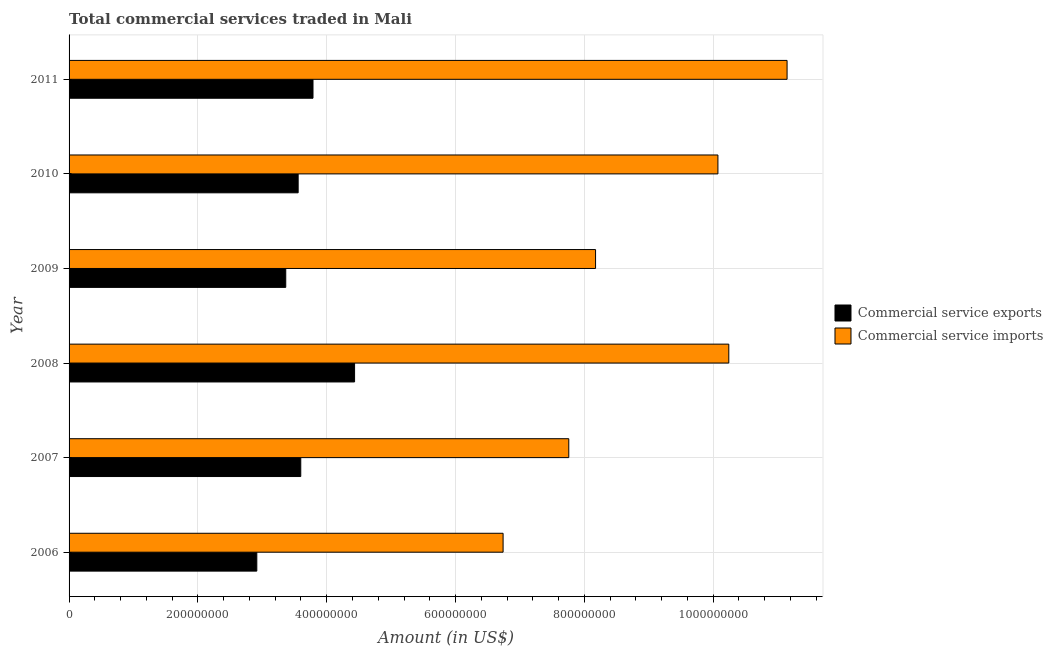How many different coloured bars are there?
Your answer should be very brief. 2. How many bars are there on the 6th tick from the bottom?
Ensure brevity in your answer.  2. What is the label of the 5th group of bars from the top?
Provide a succinct answer. 2007. In how many cases, is the number of bars for a given year not equal to the number of legend labels?
Offer a very short reply. 0. What is the amount of commercial service imports in 2007?
Provide a succinct answer. 7.76e+08. Across all years, what is the maximum amount of commercial service imports?
Offer a very short reply. 1.11e+09. Across all years, what is the minimum amount of commercial service exports?
Your answer should be very brief. 2.91e+08. In which year was the amount of commercial service imports maximum?
Your answer should be compact. 2011. What is the total amount of commercial service imports in the graph?
Give a very brief answer. 5.41e+09. What is the difference between the amount of commercial service imports in 2009 and that in 2011?
Your answer should be compact. -2.97e+08. What is the difference between the amount of commercial service imports in 2006 and the amount of commercial service exports in 2007?
Offer a very short reply. 3.14e+08. What is the average amount of commercial service imports per year?
Your response must be concise. 9.02e+08. In the year 2010, what is the difference between the amount of commercial service exports and amount of commercial service imports?
Your answer should be very brief. -6.52e+08. What is the ratio of the amount of commercial service imports in 2008 to that in 2009?
Keep it short and to the point. 1.25. What is the difference between the highest and the second highest amount of commercial service exports?
Provide a short and direct response. 6.45e+07. What is the difference between the highest and the lowest amount of commercial service exports?
Give a very brief answer. 1.52e+08. What does the 2nd bar from the top in 2009 represents?
Ensure brevity in your answer.  Commercial service exports. What does the 2nd bar from the bottom in 2007 represents?
Give a very brief answer. Commercial service imports. How many years are there in the graph?
Ensure brevity in your answer.  6. Where does the legend appear in the graph?
Your answer should be compact. Center right. What is the title of the graph?
Your response must be concise. Total commercial services traded in Mali. Does "National Visitors" appear as one of the legend labels in the graph?
Provide a succinct answer. No. What is the label or title of the X-axis?
Offer a terse response. Amount (in US$). What is the label or title of the Y-axis?
Keep it short and to the point. Year. What is the Amount (in US$) in Commercial service exports in 2006?
Your answer should be very brief. 2.91e+08. What is the Amount (in US$) of Commercial service imports in 2006?
Your answer should be compact. 6.74e+08. What is the Amount (in US$) of Commercial service exports in 2007?
Keep it short and to the point. 3.60e+08. What is the Amount (in US$) of Commercial service imports in 2007?
Keep it short and to the point. 7.76e+08. What is the Amount (in US$) in Commercial service exports in 2008?
Offer a very short reply. 4.43e+08. What is the Amount (in US$) in Commercial service imports in 2008?
Give a very brief answer. 1.02e+09. What is the Amount (in US$) of Commercial service exports in 2009?
Give a very brief answer. 3.36e+08. What is the Amount (in US$) of Commercial service imports in 2009?
Provide a short and direct response. 8.17e+08. What is the Amount (in US$) of Commercial service exports in 2010?
Offer a terse response. 3.56e+08. What is the Amount (in US$) in Commercial service imports in 2010?
Make the answer very short. 1.01e+09. What is the Amount (in US$) in Commercial service exports in 2011?
Offer a very short reply. 3.79e+08. What is the Amount (in US$) in Commercial service imports in 2011?
Offer a terse response. 1.11e+09. Across all years, what is the maximum Amount (in US$) in Commercial service exports?
Your answer should be very brief. 4.43e+08. Across all years, what is the maximum Amount (in US$) of Commercial service imports?
Ensure brevity in your answer.  1.11e+09. Across all years, what is the minimum Amount (in US$) of Commercial service exports?
Your answer should be very brief. 2.91e+08. Across all years, what is the minimum Amount (in US$) of Commercial service imports?
Your answer should be compact. 6.74e+08. What is the total Amount (in US$) of Commercial service exports in the graph?
Make the answer very short. 2.17e+09. What is the total Amount (in US$) in Commercial service imports in the graph?
Offer a very short reply. 5.41e+09. What is the difference between the Amount (in US$) in Commercial service exports in 2006 and that in 2007?
Your response must be concise. -6.82e+07. What is the difference between the Amount (in US$) in Commercial service imports in 2006 and that in 2007?
Make the answer very short. -1.02e+08. What is the difference between the Amount (in US$) of Commercial service exports in 2006 and that in 2008?
Ensure brevity in your answer.  -1.52e+08. What is the difference between the Amount (in US$) in Commercial service imports in 2006 and that in 2008?
Give a very brief answer. -3.50e+08. What is the difference between the Amount (in US$) in Commercial service exports in 2006 and that in 2009?
Provide a short and direct response. -4.49e+07. What is the difference between the Amount (in US$) of Commercial service imports in 2006 and that in 2009?
Ensure brevity in your answer.  -1.44e+08. What is the difference between the Amount (in US$) in Commercial service exports in 2006 and that in 2010?
Provide a short and direct response. -6.42e+07. What is the difference between the Amount (in US$) in Commercial service imports in 2006 and that in 2010?
Offer a terse response. -3.34e+08. What is the difference between the Amount (in US$) of Commercial service exports in 2006 and that in 2011?
Your answer should be compact. -8.72e+07. What is the difference between the Amount (in US$) in Commercial service imports in 2006 and that in 2011?
Provide a succinct answer. -4.41e+08. What is the difference between the Amount (in US$) of Commercial service exports in 2007 and that in 2008?
Your answer should be compact. -8.35e+07. What is the difference between the Amount (in US$) in Commercial service imports in 2007 and that in 2008?
Make the answer very short. -2.48e+08. What is the difference between the Amount (in US$) of Commercial service exports in 2007 and that in 2009?
Make the answer very short. 2.33e+07. What is the difference between the Amount (in US$) of Commercial service imports in 2007 and that in 2009?
Your answer should be very brief. -4.16e+07. What is the difference between the Amount (in US$) in Commercial service exports in 2007 and that in 2010?
Give a very brief answer. 4.06e+06. What is the difference between the Amount (in US$) of Commercial service imports in 2007 and that in 2010?
Offer a very short reply. -2.32e+08. What is the difference between the Amount (in US$) in Commercial service exports in 2007 and that in 2011?
Keep it short and to the point. -1.90e+07. What is the difference between the Amount (in US$) of Commercial service imports in 2007 and that in 2011?
Provide a succinct answer. -3.39e+08. What is the difference between the Amount (in US$) of Commercial service exports in 2008 and that in 2009?
Your response must be concise. 1.07e+08. What is the difference between the Amount (in US$) in Commercial service imports in 2008 and that in 2009?
Make the answer very short. 2.07e+08. What is the difference between the Amount (in US$) of Commercial service exports in 2008 and that in 2010?
Your answer should be very brief. 8.76e+07. What is the difference between the Amount (in US$) in Commercial service imports in 2008 and that in 2010?
Provide a short and direct response. 1.69e+07. What is the difference between the Amount (in US$) in Commercial service exports in 2008 and that in 2011?
Provide a succinct answer. 6.45e+07. What is the difference between the Amount (in US$) in Commercial service imports in 2008 and that in 2011?
Provide a short and direct response. -9.05e+07. What is the difference between the Amount (in US$) of Commercial service exports in 2009 and that in 2010?
Your response must be concise. -1.92e+07. What is the difference between the Amount (in US$) in Commercial service imports in 2009 and that in 2010?
Provide a succinct answer. -1.90e+08. What is the difference between the Amount (in US$) in Commercial service exports in 2009 and that in 2011?
Offer a very short reply. -4.23e+07. What is the difference between the Amount (in US$) in Commercial service imports in 2009 and that in 2011?
Provide a succinct answer. -2.97e+08. What is the difference between the Amount (in US$) of Commercial service exports in 2010 and that in 2011?
Your response must be concise. -2.30e+07. What is the difference between the Amount (in US$) of Commercial service imports in 2010 and that in 2011?
Your answer should be compact. -1.07e+08. What is the difference between the Amount (in US$) of Commercial service exports in 2006 and the Amount (in US$) of Commercial service imports in 2007?
Offer a very short reply. -4.84e+08. What is the difference between the Amount (in US$) in Commercial service exports in 2006 and the Amount (in US$) in Commercial service imports in 2008?
Keep it short and to the point. -7.33e+08. What is the difference between the Amount (in US$) in Commercial service exports in 2006 and the Amount (in US$) in Commercial service imports in 2009?
Your response must be concise. -5.26e+08. What is the difference between the Amount (in US$) of Commercial service exports in 2006 and the Amount (in US$) of Commercial service imports in 2010?
Offer a very short reply. -7.16e+08. What is the difference between the Amount (in US$) of Commercial service exports in 2006 and the Amount (in US$) of Commercial service imports in 2011?
Provide a short and direct response. -8.23e+08. What is the difference between the Amount (in US$) of Commercial service exports in 2007 and the Amount (in US$) of Commercial service imports in 2008?
Keep it short and to the point. -6.64e+08. What is the difference between the Amount (in US$) in Commercial service exports in 2007 and the Amount (in US$) in Commercial service imports in 2009?
Give a very brief answer. -4.58e+08. What is the difference between the Amount (in US$) in Commercial service exports in 2007 and the Amount (in US$) in Commercial service imports in 2010?
Provide a short and direct response. -6.48e+08. What is the difference between the Amount (in US$) in Commercial service exports in 2007 and the Amount (in US$) in Commercial service imports in 2011?
Your answer should be compact. -7.55e+08. What is the difference between the Amount (in US$) of Commercial service exports in 2008 and the Amount (in US$) of Commercial service imports in 2009?
Your answer should be compact. -3.74e+08. What is the difference between the Amount (in US$) in Commercial service exports in 2008 and the Amount (in US$) in Commercial service imports in 2010?
Offer a very short reply. -5.64e+08. What is the difference between the Amount (in US$) of Commercial service exports in 2008 and the Amount (in US$) of Commercial service imports in 2011?
Your answer should be very brief. -6.71e+08. What is the difference between the Amount (in US$) of Commercial service exports in 2009 and the Amount (in US$) of Commercial service imports in 2010?
Your response must be concise. -6.71e+08. What is the difference between the Amount (in US$) in Commercial service exports in 2009 and the Amount (in US$) in Commercial service imports in 2011?
Provide a short and direct response. -7.78e+08. What is the difference between the Amount (in US$) of Commercial service exports in 2010 and the Amount (in US$) of Commercial service imports in 2011?
Make the answer very short. -7.59e+08. What is the average Amount (in US$) in Commercial service exports per year?
Your answer should be compact. 3.61e+08. What is the average Amount (in US$) of Commercial service imports per year?
Your answer should be compact. 9.02e+08. In the year 2006, what is the difference between the Amount (in US$) in Commercial service exports and Amount (in US$) in Commercial service imports?
Ensure brevity in your answer.  -3.82e+08. In the year 2007, what is the difference between the Amount (in US$) in Commercial service exports and Amount (in US$) in Commercial service imports?
Offer a terse response. -4.16e+08. In the year 2008, what is the difference between the Amount (in US$) of Commercial service exports and Amount (in US$) of Commercial service imports?
Your answer should be compact. -5.81e+08. In the year 2009, what is the difference between the Amount (in US$) in Commercial service exports and Amount (in US$) in Commercial service imports?
Make the answer very short. -4.81e+08. In the year 2010, what is the difference between the Amount (in US$) of Commercial service exports and Amount (in US$) of Commercial service imports?
Your answer should be compact. -6.52e+08. In the year 2011, what is the difference between the Amount (in US$) of Commercial service exports and Amount (in US$) of Commercial service imports?
Keep it short and to the point. -7.36e+08. What is the ratio of the Amount (in US$) of Commercial service exports in 2006 to that in 2007?
Provide a short and direct response. 0.81. What is the ratio of the Amount (in US$) of Commercial service imports in 2006 to that in 2007?
Provide a short and direct response. 0.87. What is the ratio of the Amount (in US$) of Commercial service exports in 2006 to that in 2008?
Your answer should be very brief. 0.66. What is the ratio of the Amount (in US$) in Commercial service imports in 2006 to that in 2008?
Ensure brevity in your answer.  0.66. What is the ratio of the Amount (in US$) in Commercial service exports in 2006 to that in 2009?
Offer a very short reply. 0.87. What is the ratio of the Amount (in US$) in Commercial service imports in 2006 to that in 2009?
Offer a terse response. 0.82. What is the ratio of the Amount (in US$) of Commercial service exports in 2006 to that in 2010?
Offer a terse response. 0.82. What is the ratio of the Amount (in US$) in Commercial service imports in 2006 to that in 2010?
Provide a succinct answer. 0.67. What is the ratio of the Amount (in US$) of Commercial service exports in 2006 to that in 2011?
Your answer should be compact. 0.77. What is the ratio of the Amount (in US$) in Commercial service imports in 2006 to that in 2011?
Give a very brief answer. 0.6. What is the ratio of the Amount (in US$) in Commercial service exports in 2007 to that in 2008?
Your answer should be compact. 0.81. What is the ratio of the Amount (in US$) of Commercial service imports in 2007 to that in 2008?
Keep it short and to the point. 0.76. What is the ratio of the Amount (in US$) in Commercial service exports in 2007 to that in 2009?
Ensure brevity in your answer.  1.07. What is the ratio of the Amount (in US$) in Commercial service imports in 2007 to that in 2009?
Give a very brief answer. 0.95. What is the ratio of the Amount (in US$) in Commercial service exports in 2007 to that in 2010?
Your response must be concise. 1.01. What is the ratio of the Amount (in US$) of Commercial service imports in 2007 to that in 2010?
Keep it short and to the point. 0.77. What is the ratio of the Amount (in US$) of Commercial service exports in 2007 to that in 2011?
Provide a short and direct response. 0.95. What is the ratio of the Amount (in US$) of Commercial service imports in 2007 to that in 2011?
Provide a succinct answer. 0.7. What is the ratio of the Amount (in US$) in Commercial service exports in 2008 to that in 2009?
Your answer should be very brief. 1.32. What is the ratio of the Amount (in US$) of Commercial service imports in 2008 to that in 2009?
Offer a very short reply. 1.25. What is the ratio of the Amount (in US$) in Commercial service exports in 2008 to that in 2010?
Your response must be concise. 1.25. What is the ratio of the Amount (in US$) of Commercial service imports in 2008 to that in 2010?
Make the answer very short. 1.02. What is the ratio of the Amount (in US$) of Commercial service exports in 2008 to that in 2011?
Your response must be concise. 1.17. What is the ratio of the Amount (in US$) in Commercial service imports in 2008 to that in 2011?
Your answer should be compact. 0.92. What is the ratio of the Amount (in US$) of Commercial service exports in 2009 to that in 2010?
Keep it short and to the point. 0.95. What is the ratio of the Amount (in US$) of Commercial service imports in 2009 to that in 2010?
Provide a succinct answer. 0.81. What is the ratio of the Amount (in US$) in Commercial service exports in 2009 to that in 2011?
Offer a very short reply. 0.89. What is the ratio of the Amount (in US$) of Commercial service imports in 2009 to that in 2011?
Make the answer very short. 0.73. What is the ratio of the Amount (in US$) in Commercial service exports in 2010 to that in 2011?
Give a very brief answer. 0.94. What is the ratio of the Amount (in US$) in Commercial service imports in 2010 to that in 2011?
Offer a terse response. 0.9. What is the difference between the highest and the second highest Amount (in US$) of Commercial service exports?
Ensure brevity in your answer.  6.45e+07. What is the difference between the highest and the second highest Amount (in US$) of Commercial service imports?
Offer a terse response. 9.05e+07. What is the difference between the highest and the lowest Amount (in US$) in Commercial service exports?
Make the answer very short. 1.52e+08. What is the difference between the highest and the lowest Amount (in US$) in Commercial service imports?
Your answer should be very brief. 4.41e+08. 